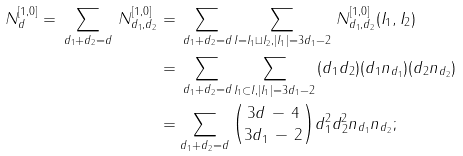<formula> <loc_0><loc_0><loc_500><loc_500>N _ { d } ^ { [ 1 , 0 ] } = \, \sum _ { d _ { 1 } + d _ { 2 } = d } \, N _ { d _ { 1 } , d _ { 2 } } ^ { [ 1 , 0 ] } & = \, \sum _ { d _ { 1 } + d _ { 2 } = d } \sum _ { I = I _ { 1 } \sqcup I _ { 2 } , | I _ { 1 } | = 3 d _ { 1 } - 2 } \, N _ { d _ { 1 } , d _ { 2 } } ^ { [ 1 , 0 ] } ( I _ { 1 } , I _ { 2 } ) \\ & = \, \sum _ { d _ { 1 } + d _ { 2 } = d } \sum _ { I _ { 1 } \subset I , | I _ { 1 } | = 3 d _ { 1 } - 2 } \, ( d _ { 1 } d _ { 2 } ) ( d _ { 1 } n _ { d _ { 1 } } ) ( d _ { 2 } n _ { d _ { 2 } } ) \\ & = \sum _ { d _ { 1 } + d _ { 2 } = d } \binom { 3 d \, - \, 4 } { 3 d _ { 1 } \, - \, 2 } d _ { 1 } ^ { 2 } d _ { 2 } ^ { 2 } n _ { d _ { 1 } } n _ { d _ { 2 } } ;</formula> 